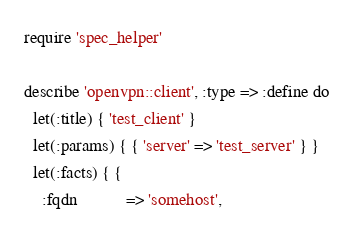<code> <loc_0><loc_0><loc_500><loc_500><_Ruby_>require 'spec_helper'

describe 'openvpn::client', :type => :define do
  let(:title) { 'test_client' }
  let(:params) { { 'server' => 'test_server' } }
  let(:facts) { {
    :fqdn           => 'somehost',</code> 